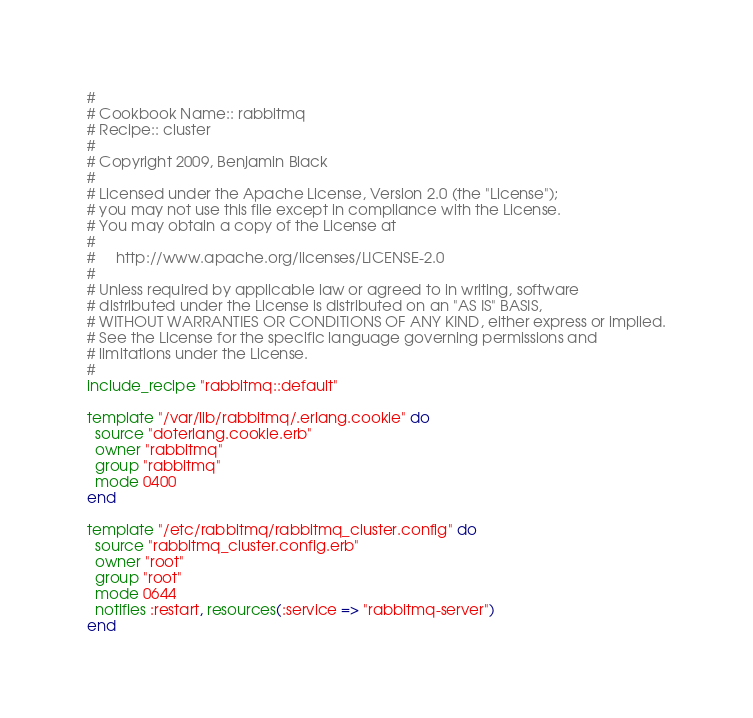Convert code to text. <code><loc_0><loc_0><loc_500><loc_500><_Ruby_>#
# Cookbook Name:: rabbitmq
# Recipe:: cluster
#
# Copyright 2009, Benjamin Black
#
# Licensed under the Apache License, Version 2.0 (the "License");
# you may not use this file except in compliance with the License.
# You may obtain a copy of the License at
# 
#     http://www.apache.org/licenses/LICENSE-2.0
# 
# Unless required by applicable law or agreed to in writing, software
# distributed under the License is distributed on an "AS IS" BASIS,
# WITHOUT WARRANTIES OR CONDITIONS OF ANY KIND, either express or implied.
# See the License for the specific language governing permissions and
# limitations under the License.
#
include_recipe "rabbitmq::default"

template "/var/lib/rabbitmq/.erlang.cookie" do
  source "doterlang.cookie.erb"
  owner "rabbitmq"
  group "rabbitmq"
  mode 0400
end

template "/etc/rabbitmq/rabbitmq_cluster.config" do
  source "rabbitmq_cluster.config.erb"
  owner "root"
  group "root"
  mode 0644
  notifies :restart, resources(:service => "rabbitmq-server")
end

</code> 